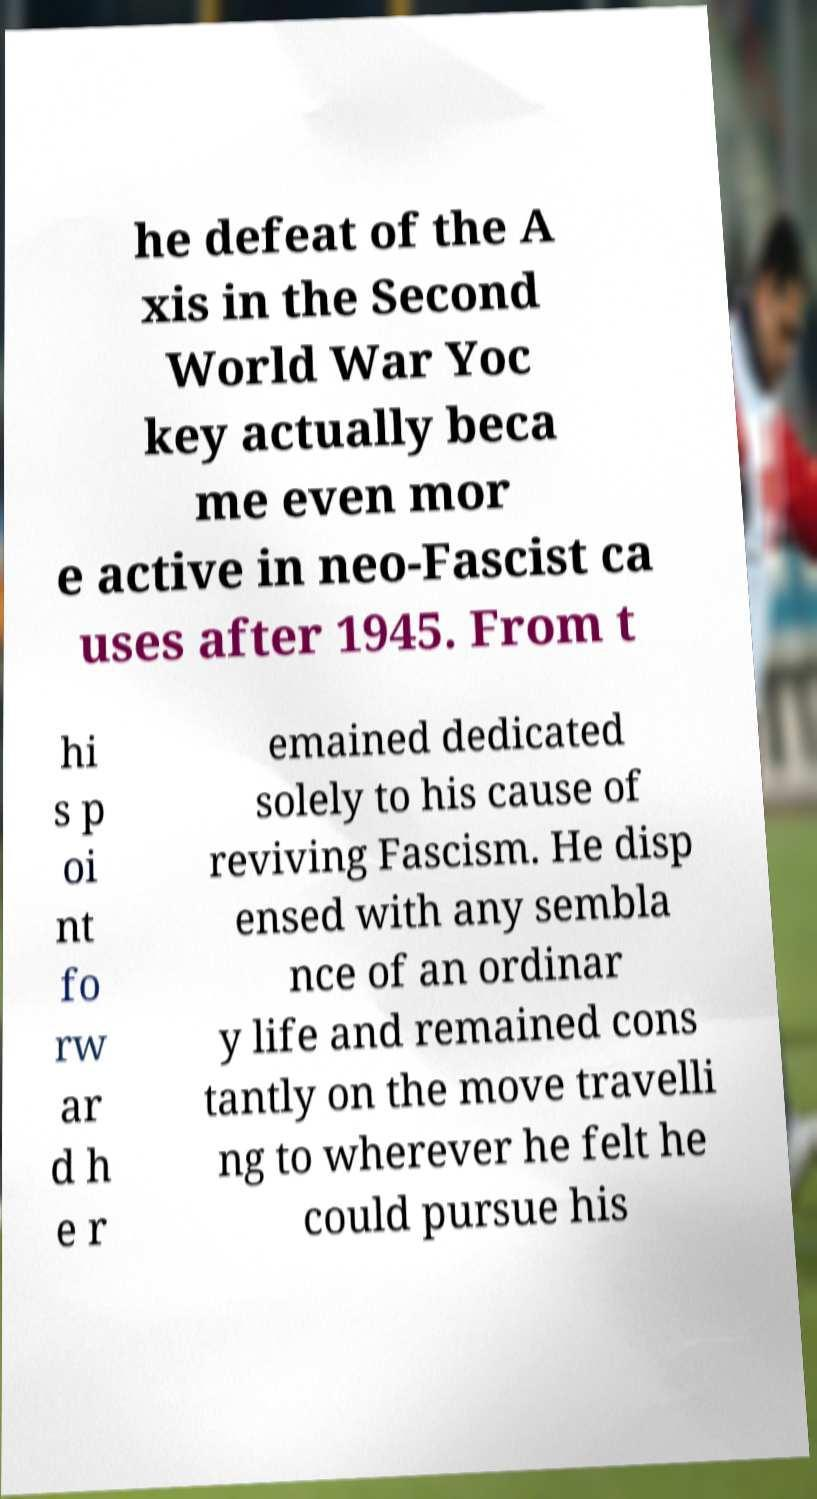Can you read and provide the text displayed in the image?This photo seems to have some interesting text. Can you extract and type it out for me? he defeat of the A xis in the Second World War Yoc key actually beca me even mor e active in neo-Fascist ca uses after 1945. From t hi s p oi nt fo rw ar d h e r emained dedicated solely to his cause of reviving Fascism. He disp ensed with any sembla nce of an ordinar y life and remained cons tantly on the move travelli ng to wherever he felt he could pursue his 